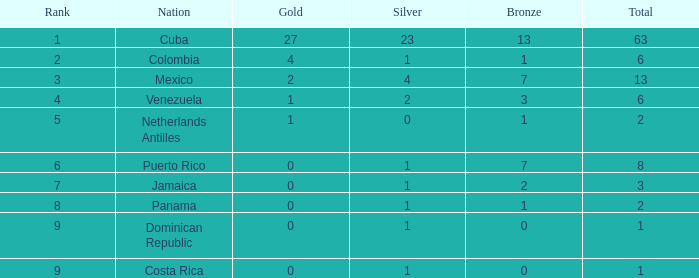What nation holds the least gold average having a rank beyond 9? None. 